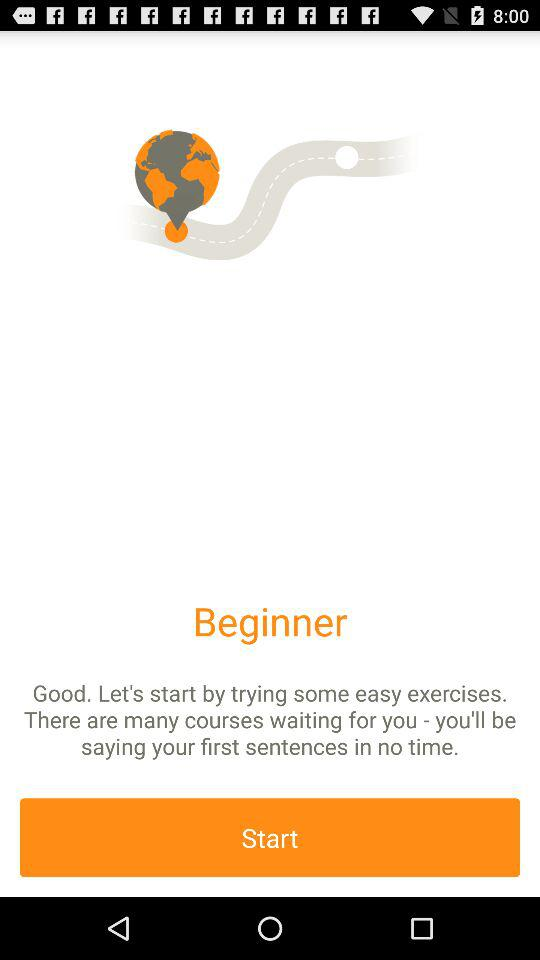What is the application name? The application name is "Babbel". 